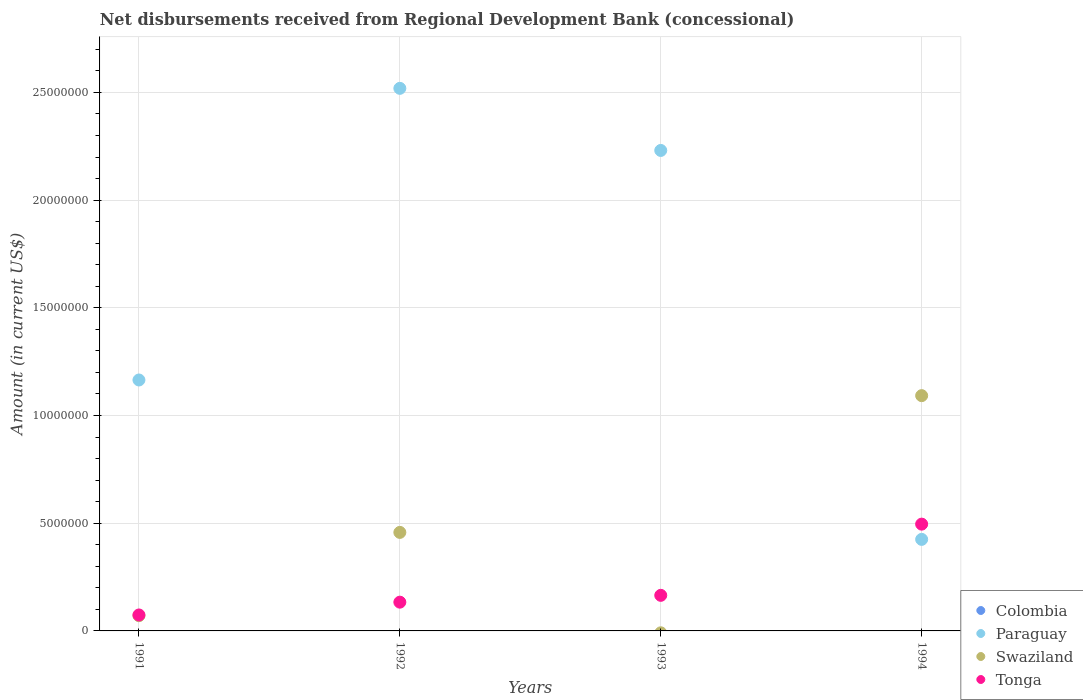How many different coloured dotlines are there?
Offer a terse response. 3. What is the amount of disbursements received from Regional Development Bank in Swaziland in 1993?
Offer a very short reply. 0. Across all years, what is the maximum amount of disbursements received from Regional Development Bank in Paraguay?
Provide a short and direct response. 2.52e+07. Across all years, what is the minimum amount of disbursements received from Regional Development Bank in Paraguay?
Make the answer very short. 4.25e+06. In which year was the amount of disbursements received from Regional Development Bank in Paraguay maximum?
Keep it short and to the point. 1992. What is the total amount of disbursements received from Regional Development Bank in Tonga in the graph?
Your answer should be compact. 8.69e+06. What is the difference between the amount of disbursements received from Regional Development Bank in Paraguay in 1992 and that in 1994?
Offer a very short reply. 2.09e+07. What is the difference between the amount of disbursements received from Regional Development Bank in Paraguay in 1993 and the amount of disbursements received from Regional Development Bank in Swaziland in 1994?
Provide a short and direct response. 1.14e+07. What is the average amount of disbursements received from Regional Development Bank in Colombia per year?
Make the answer very short. 0. In the year 1991, what is the difference between the amount of disbursements received from Regional Development Bank in Swaziland and amount of disbursements received from Regional Development Bank in Tonga?
Your answer should be compact. -3.40e+04. In how many years, is the amount of disbursements received from Regional Development Bank in Tonga greater than 10000000 US$?
Provide a short and direct response. 0. What is the ratio of the amount of disbursements received from Regional Development Bank in Swaziland in 1992 to that in 1994?
Make the answer very short. 0.42. Is the amount of disbursements received from Regional Development Bank in Swaziland in 1991 less than that in 1992?
Ensure brevity in your answer.  Yes. What is the difference between the highest and the second highest amount of disbursements received from Regional Development Bank in Tonga?
Give a very brief answer. 3.31e+06. What is the difference between the highest and the lowest amount of disbursements received from Regional Development Bank in Paraguay?
Your answer should be very brief. 2.09e+07. Is it the case that in every year, the sum of the amount of disbursements received from Regional Development Bank in Tonga and amount of disbursements received from Regional Development Bank in Paraguay  is greater than the sum of amount of disbursements received from Regional Development Bank in Colombia and amount of disbursements received from Regional Development Bank in Swaziland?
Provide a short and direct response. Yes. Is it the case that in every year, the sum of the amount of disbursements received from Regional Development Bank in Paraguay and amount of disbursements received from Regional Development Bank in Swaziland  is greater than the amount of disbursements received from Regional Development Bank in Colombia?
Offer a terse response. Yes. Is the amount of disbursements received from Regional Development Bank in Tonga strictly greater than the amount of disbursements received from Regional Development Bank in Swaziland over the years?
Give a very brief answer. No. Is the amount of disbursements received from Regional Development Bank in Swaziland strictly less than the amount of disbursements received from Regional Development Bank in Paraguay over the years?
Give a very brief answer. No. How many dotlines are there?
Your answer should be very brief. 3. How many years are there in the graph?
Your answer should be very brief. 4. Are the values on the major ticks of Y-axis written in scientific E-notation?
Ensure brevity in your answer.  No. Does the graph contain grids?
Give a very brief answer. Yes. What is the title of the graph?
Offer a terse response. Net disbursements received from Regional Development Bank (concessional). What is the label or title of the Y-axis?
Your response must be concise. Amount (in current US$). What is the Amount (in current US$) of Colombia in 1991?
Offer a very short reply. 0. What is the Amount (in current US$) of Paraguay in 1991?
Make the answer very short. 1.16e+07. What is the Amount (in current US$) in Swaziland in 1991?
Keep it short and to the point. 7.07e+05. What is the Amount (in current US$) of Tonga in 1991?
Keep it short and to the point. 7.41e+05. What is the Amount (in current US$) in Paraguay in 1992?
Make the answer very short. 2.52e+07. What is the Amount (in current US$) in Swaziland in 1992?
Your answer should be very brief. 4.57e+06. What is the Amount (in current US$) in Tonga in 1992?
Provide a succinct answer. 1.34e+06. What is the Amount (in current US$) in Colombia in 1993?
Your answer should be compact. 0. What is the Amount (in current US$) of Paraguay in 1993?
Offer a terse response. 2.23e+07. What is the Amount (in current US$) of Swaziland in 1993?
Offer a very short reply. 0. What is the Amount (in current US$) in Tonga in 1993?
Offer a terse response. 1.65e+06. What is the Amount (in current US$) of Colombia in 1994?
Offer a terse response. 0. What is the Amount (in current US$) of Paraguay in 1994?
Your response must be concise. 4.25e+06. What is the Amount (in current US$) of Swaziland in 1994?
Your answer should be very brief. 1.09e+07. What is the Amount (in current US$) of Tonga in 1994?
Your answer should be very brief. 4.96e+06. Across all years, what is the maximum Amount (in current US$) in Paraguay?
Offer a very short reply. 2.52e+07. Across all years, what is the maximum Amount (in current US$) in Swaziland?
Your answer should be very brief. 1.09e+07. Across all years, what is the maximum Amount (in current US$) of Tonga?
Your answer should be very brief. 4.96e+06. Across all years, what is the minimum Amount (in current US$) of Paraguay?
Offer a terse response. 4.25e+06. Across all years, what is the minimum Amount (in current US$) of Tonga?
Your answer should be compact. 7.41e+05. What is the total Amount (in current US$) in Paraguay in the graph?
Keep it short and to the point. 6.34e+07. What is the total Amount (in current US$) in Swaziland in the graph?
Provide a succinct answer. 1.62e+07. What is the total Amount (in current US$) of Tonga in the graph?
Provide a short and direct response. 8.69e+06. What is the difference between the Amount (in current US$) of Paraguay in 1991 and that in 1992?
Keep it short and to the point. -1.35e+07. What is the difference between the Amount (in current US$) in Swaziland in 1991 and that in 1992?
Make the answer very short. -3.87e+06. What is the difference between the Amount (in current US$) of Tonga in 1991 and that in 1992?
Ensure brevity in your answer.  -5.94e+05. What is the difference between the Amount (in current US$) of Paraguay in 1991 and that in 1993?
Make the answer very short. -1.07e+07. What is the difference between the Amount (in current US$) of Tonga in 1991 and that in 1993?
Offer a very short reply. -9.11e+05. What is the difference between the Amount (in current US$) in Paraguay in 1991 and that in 1994?
Your response must be concise. 7.40e+06. What is the difference between the Amount (in current US$) in Swaziland in 1991 and that in 1994?
Ensure brevity in your answer.  -1.02e+07. What is the difference between the Amount (in current US$) in Tonga in 1991 and that in 1994?
Make the answer very short. -4.22e+06. What is the difference between the Amount (in current US$) in Paraguay in 1992 and that in 1993?
Keep it short and to the point. 2.88e+06. What is the difference between the Amount (in current US$) of Tonga in 1992 and that in 1993?
Provide a succinct answer. -3.17e+05. What is the difference between the Amount (in current US$) of Paraguay in 1992 and that in 1994?
Ensure brevity in your answer.  2.09e+07. What is the difference between the Amount (in current US$) of Swaziland in 1992 and that in 1994?
Your answer should be very brief. -6.35e+06. What is the difference between the Amount (in current US$) of Tonga in 1992 and that in 1994?
Give a very brief answer. -3.62e+06. What is the difference between the Amount (in current US$) of Paraguay in 1993 and that in 1994?
Make the answer very short. 1.81e+07. What is the difference between the Amount (in current US$) in Tonga in 1993 and that in 1994?
Your answer should be compact. -3.31e+06. What is the difference between the Amount (in current US$) of Paraguay in 1991 and the Amount (in current US$) of Swaziland in 1992?
Your answer should be compact. 7.08e+06. What is the difference between the Amount (in current US$) in Paraguay in 1991 and the Amount (in current US$) in Tonga in 1992?
Keep it short and to the point. 1.03e+07. What is the difference between the Amount (in current US$) in Swaziland in 1991 and the Amount (in current US$) in Tonga in 1992?
Give a very brief answer. -6.28e+05. What is the difference between the Amount (in current US$) in Paraguay in 1991 and the Amount (in current US$) in Tonga in 1993?
Give a very brief answer. 1.00e+07. What is the difference between the Amount (in current US$) of Swaziland in 1991 and the Amount (in current US$) of Tonga in 1993?
Offer a terse response. -9.45e+05. What is the difference between the Amount (in current US$) of Paraguay in 1991 and the Amount (in current US$) of Swaziland in 1994?
Your response must be concise. 7.27e+05. What is the difference between the Amount (in current US$) of Paraguay in 1991 and the Amount (in current US$) of Tonga in 1994?
Make the answer very short. 6.69e+06. What is the difference between the Amount (in current US$) of Swaziland in 1991 and the Amount (in current US$) of Tonga in 1994?
Keep it short and to the point. -4.25e+06. What is the difference between the Amount (in current US$) in Paraguay in 1992 and the Amount (in current US$) in Tonga in 1993?
Ensure brevity in your answer.  2.35e+07. What is the difference between the Amount (in current US$) in Swaziland in 1992 and the Amount (in current US$) in Tonga in 1993?
Offer a very short reply. 2.92e+06. What is the difference between the Amount (in current US$) in Paraguay in 1992 and the Amount (in current US$) in Swaziland in 1994?
Provide a short and direct response. 1.43e+07. What is the difference between the Amount (in current US$) in Paraguay in 1992 and the Amount (in current US$) in Tonga in 1994?
Provide a succinct answer. 2.02e+07. What is the difference between the Amount (in current US$) in Swaziland in 1992 and the Amount (in current US$) in Tonga in 1994?
Provide a succinct answer. -3.84e+05. What is the difference between the Amount (in current US$) in Paraguay in 1993 and the Amount (in current US$) in Swaziland in 1994?
Provide a short and direct response. 1.14e+07. What is the difference between the Amount (in current US$) in Paraguay in 1993 and the Amount (in current US$) in Tonga in 1994?
Keep it short and to the point. 1.73e+07. What is the average Amount (in current US$) in Colombia per year?
Provide a short and direct response. 0. What is the average Amount (in current US$) of Paraguay per year?
Provide a succinct answer. 1.58e+07. What is the average Amount (in current US$) in Swaziland per year?
Your response must be concise. 4.05e+06. What is the average Amount (in current US$) of Tonga per year?
Keep it short and to the point. 2.17e+06. In the year 1991, what is the difference between the Amount (in current US$) in Paraguay and Amount (in current US$) in Swaziland?
Ensure brevity in your answer.  1.09e+07. In the year 1991, what is the difference between the Amount (in current US$) of Paraguay and Amount (in current US$) of Tonga?
Offer a very short reply. 1.09e+07. In the year 1991, what is the difference between the Amount (in current US$) in Swaziland and Amount (in current US$) in Tonga?
Your answer should be compact. -3.40e+04. In the year 1992, what is the difference between the Amount (in current US$) of Paraguay and Amount (in current US$) of Swaziland?
Keep it short and to the point. 2.06e+07. In the year 1992, what is the difference between the Amount (in current US$) in Paraguay and Amount (in current US$) in Tonga?
Your answer should be compact. 2.39e+07. In the year 1992, what is the difference between the Amount (in current US$) in Swaziland and Amount (in current US$) in Tonga?
Offer a terse response. 3.24e+06. In the year 1993, what is the difference between the Amount (in current US$) of Paraguay and Amount (in current US$) of Tonga?
Ensure brevity in your answer.  2.07e+07. In the year 1994, what is the difference between the Amount (in current US$) in Paraguay and Amount (in current US$) in Swaziland?
Provide a short and direct response. -6.67e+06. In the year 1994, what is the difference between the Amount (in current US$) in Paraguay and Amount (in current US$) in Tonga?
Your answer should be very brief. -7.08e+05. In the year 1994, what is the difference between the Amount (in current US$) of Swaziland and Amount (in current US$) of Tonga?
Provide a succinct answer. 5.96e+06. What is the ratio of the Amount (in current US$) of Paraguay in 1991 to that in 1992?
Make the answer very short. 0.46. What is the ratio of the Amount (in current US$) in Swaziland in 1991 to that in 1992?
Provide a succinct answer. 0.15. What is the ratio of the Amount (in current US$) in Tonga in 1991 to that in 1992?
Offer a very short reply. 0.56. What is the ratio of the Amount (in current US$) of Paraguay in 1991 to that in 1993?
Provide a short and direct response. 0.52. What is the ratio of the Amount (in current US$) in Tonga in 1991 to that in 1993?
Provide a succinct answer. 0.45. What is the ratio of the Amount (in current US$) in Paraguay in 1991 to that in 1994?
Offer a terse response. 2.74. What is the ratio of the Amount (in current US$) of Swaziland in 1991 to that in 1994?
Offer a terse response. 0.06. What is the ratio of the Amount (in current US$) in Tonga in 1991 to that in 1994?
Make the answer very short. 0.15. What is the ratio of the Amount (in current US$) of Paraguay in 1992 to that in 1993?
Ensure brevity in your answer.  1.13. What is the ratio of the Amount (in current US$) in Tonga in 1992 to that in 1993?
Keep it short and to the point. 0.81. What is the ratio of the Amount (in current US$) in Paraguay in 1992 to that in 1994?
Your answer should be very brief. 5.93. What is the ratio of the Amount (in current US$) of Swaziland in 1992 to that in 1994?
Ensure brevity in your answer.  0.42. What is the ratio of the Amount (in current US$) of Tonga in 1992 to that in 1994?
Give a very brief answer. 0.27. What is the ratio of the Amount (in current US$) in Paraguay in 1993 to that in 1994?
Offer a very short reply. 5.25. What is the ratio of the Amount (in current US$) in Tonga in 1993 to that in 1994?
Offer a terse response. 0.33. What is the difference between the highest and the second highest Amount (in current US$) of Paraguay?
Make the answer very short. 2.88e+06. What is the difference between the highest and the second highest Amount (in current US$) of Swaziland?
Give a very brief answer. 6.35e+06. What is the difference between the highest and the second highest Amount (in current US$) in Tonga?
Keep it short and to the point. 3.31e+06. What is the difference between the highest and the lowest Amount (in current US$) of Paraguay?
Make the answer very short. 2.09e+07. What is the difference between the highest and the lowest Amount (in current US$) of Swaziland?
Your answer should be very brief. 1.09e+07. What is the difference between the highest and the lowest Amount (in current US$) in Tonga?
Your response must be concise. 4.22e+06. 